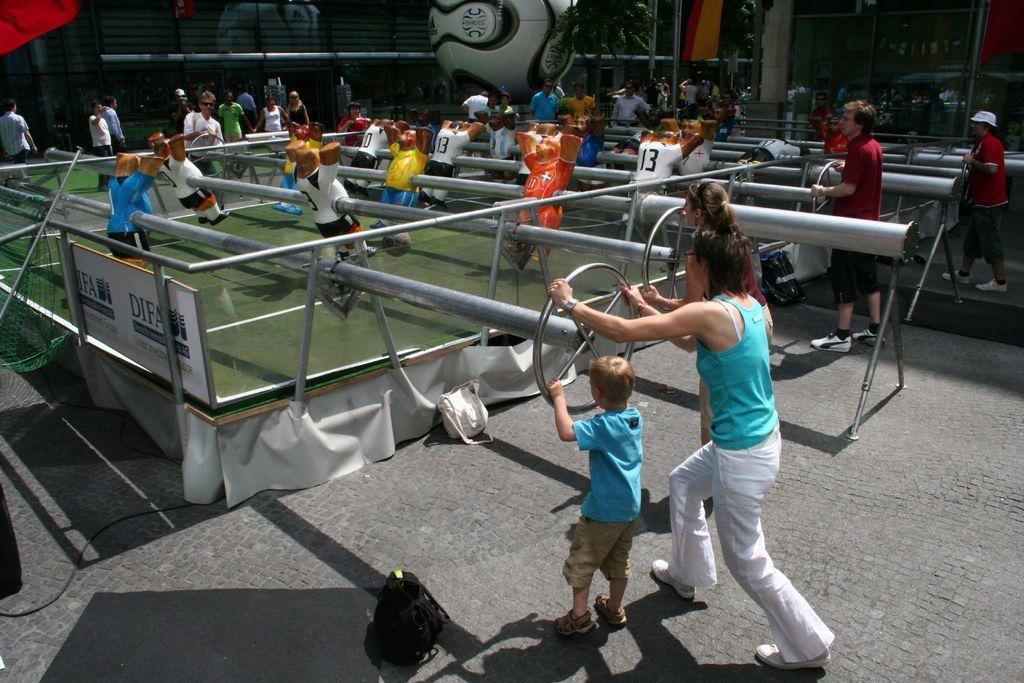In one or two sentences, can you explain what this image depicts? This picture describes about group of people, few people are playing game, and they are holding metal rods, in the background we can see a tree, few buildings and a ball. 